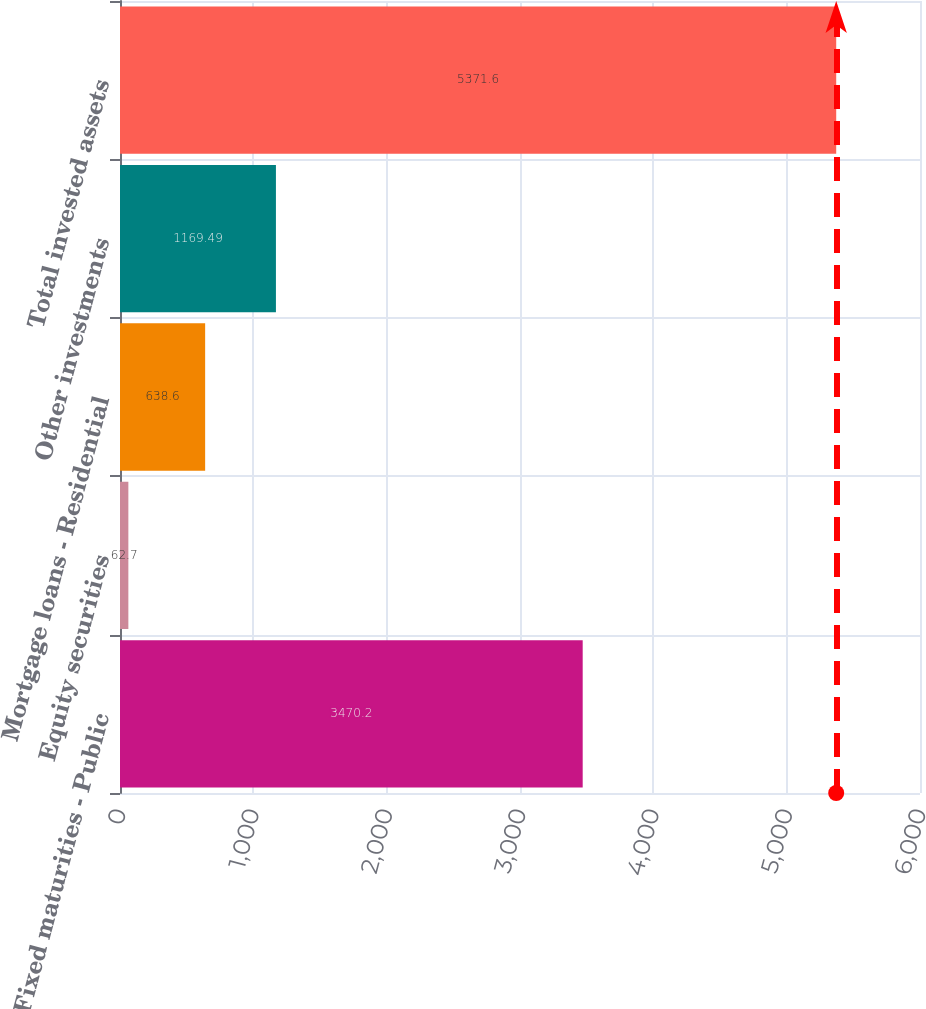<chart> <loc_0><loc_0><loc_500><loc_500><bar_chart><fcel>Fixed maturities - Public<fcel>Equity securities<fcel>Mortgage loans - Residential<fcel>Other investments<fcel>Total invested assets<nl><fcel>3470.2<fcel>62.7<fcel>638.6<fcel>1169.49<fcel>5371.6<nl></chart> 